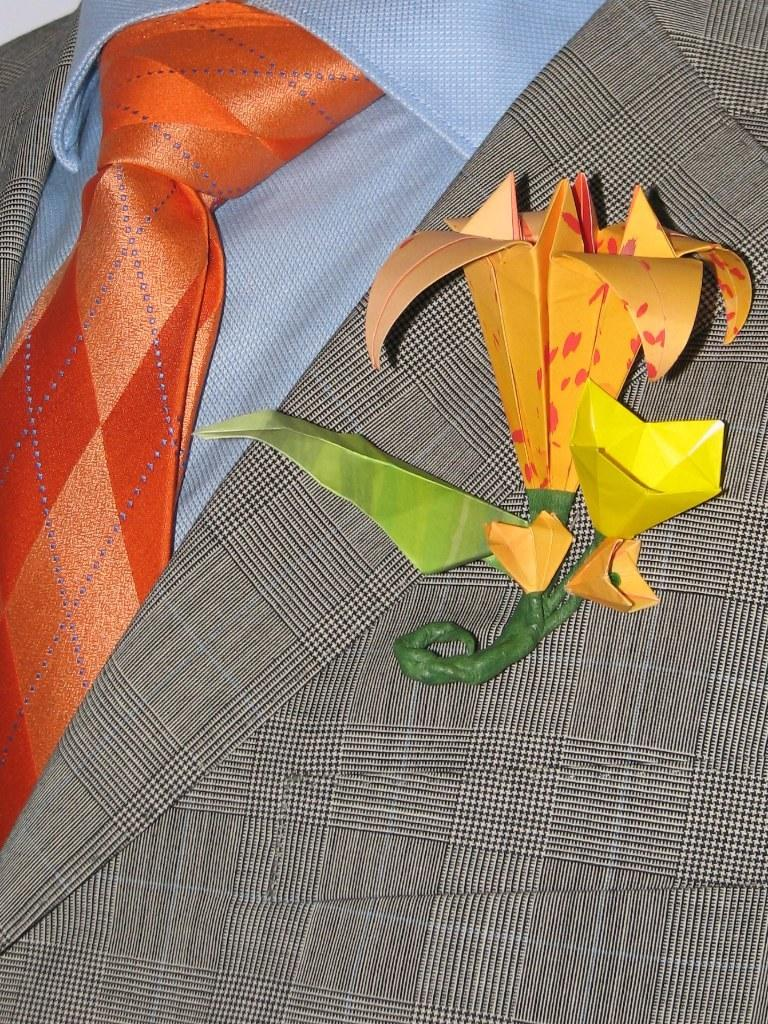What type of clothing accessory is present in the image? There is an orange color tie in the image. What type of clothing is present in the image? There is a grey color jacket in the image. What non-clothing item is present in the image? There is a flower in the image. What type of bean is present in the image? There is no bean present in the image. What type of punishment is being depicted in the image? There is no punishment being depicted in the image. What type of drug is being used in the image? There is no drug being used in the image. 